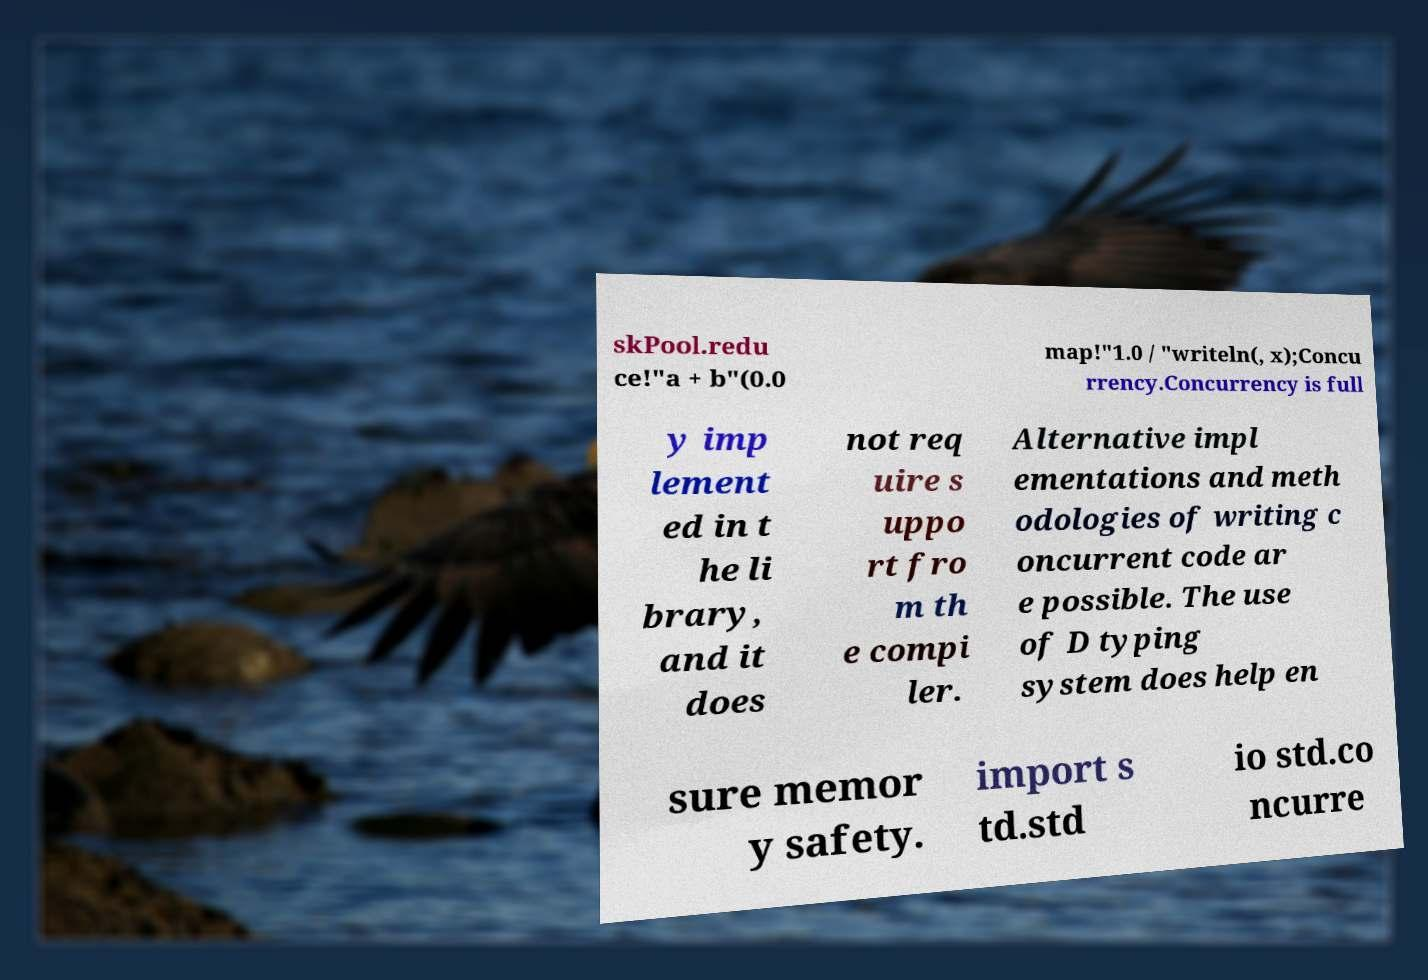Can you read and provide the text displayed in the image?This photo seems to have some interesting text. Can you extract and type it out for me? skPool.redu ce!"a + b"(0.0 map!"1.0 / "writeln(, x);Concu rrency.Concurrency is full y imp lement ed in t he li brary, and it does not req uire s uppo rt fro m th e compi ler. Alternative impl ementations and meth odologies of writing c oncurrent code ar e possible. The use of D typing system does help en sure memor y safety. import s td.std io std.co ncurre 